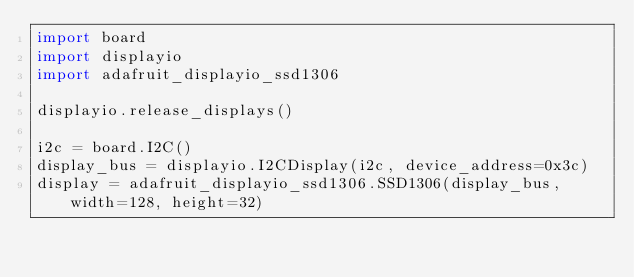<code> <loc_0><loc_0><loc_500><loc_500><_Python_>import board
import displayio
import adafruit_displayio_ssd1306

displayio.release_displays()

i2c = board.I2C()
display_bus = displayio.I2CDisplay(i2c, device_address=0x3c)
display = adafruit_displayio_ssd1306.SSD1306(display_bus, width=128, height=32)
</code> 